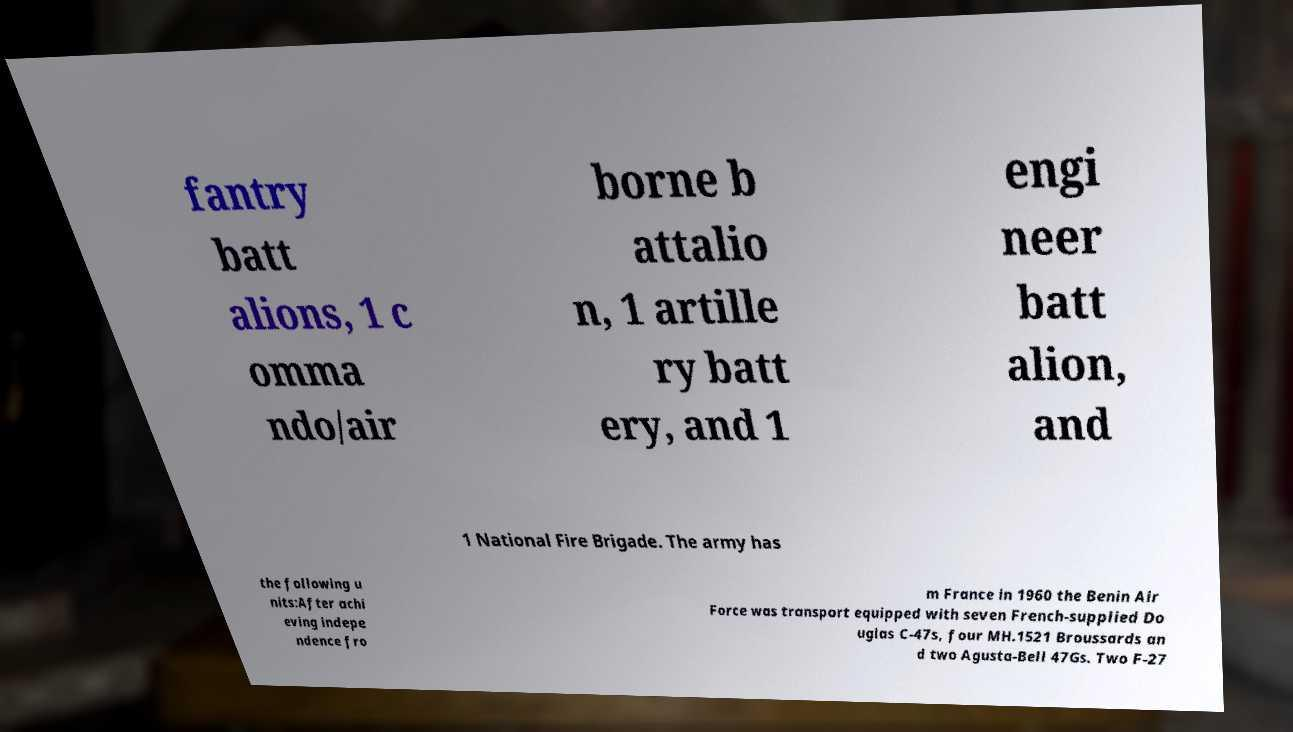Can you read and provide the text displayed in the image?This photo seems to have some interesting text. Can you extract and type it out for me? fantry batt alions, 1 c omma ndo/air borne b attalio n, 1 artille ry batt ery, and 1 engi neer batt alion, and 1 National Fire Brigade. The army has the following u nits:After achi eving indepe ndence fro m France in 1960 the Benin Air Force was transport equipped with seven French-supplied Do uglas C-47s, four MH.1521 Broussards an d two Agusta-Bell 47Gs. Two F-27 